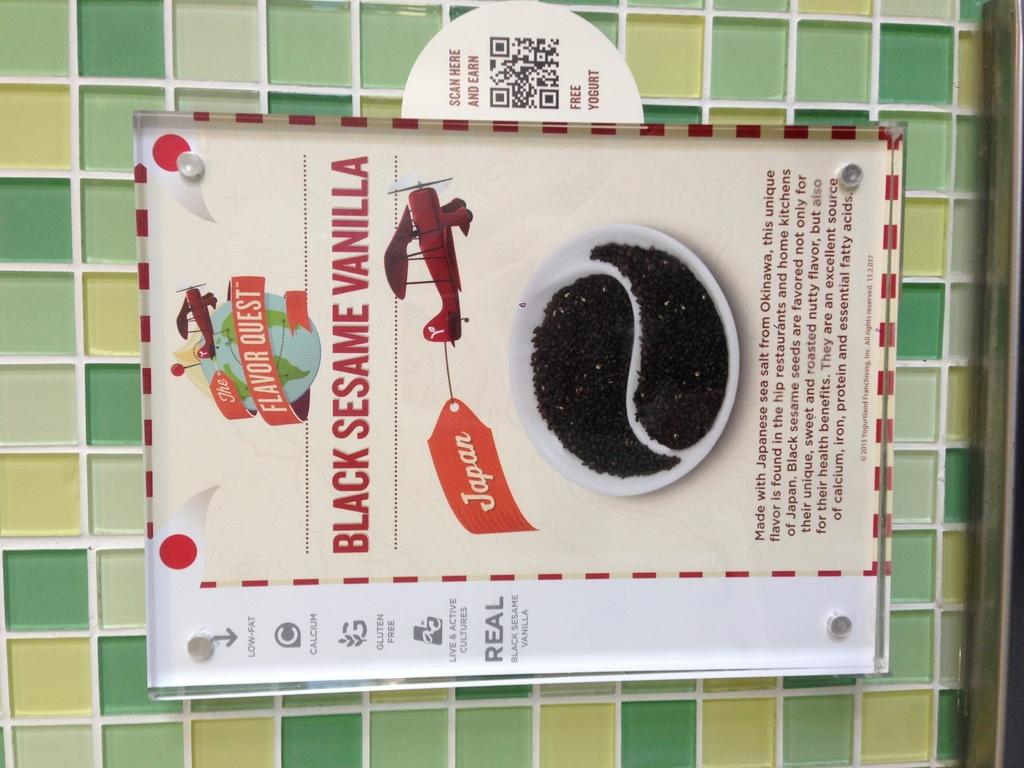<image>
Create a compact narrative representing the image presented. A sign for black sesame vanilla has a little red airplane on it. 